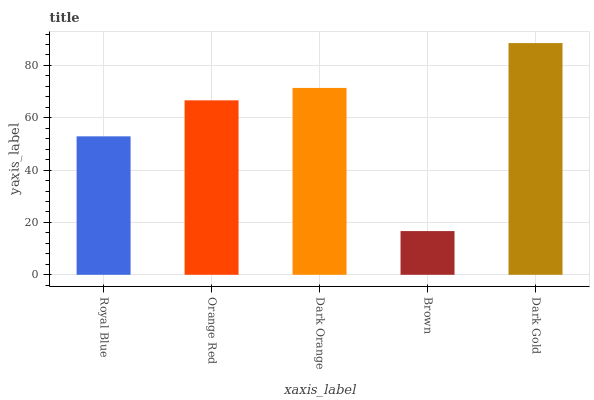Is Orange Red the minimum?
Answer yes or no. No. Is Orange Red the maximum?
Answer yes or no. No. Is Orange Red greater than Royal Blue?
Answer yes or no. Yes. Is Royal Blue less than Orange Red?
Answer yes or no. Yes. Is Royal Blue greater than Orange Red?
Answer yes or no. No. Is Orange Red less than Royal Blue?
Answer yes or no. No. Is Orange Red the high median?
Answer yes or no. Yes. Is Orange Red the low median?
Answer yes or no. Yes. Is Dark Orange the high median?
Answer yes or no. No. Is Royal Blue the low median?
Answer yes or no. No. 